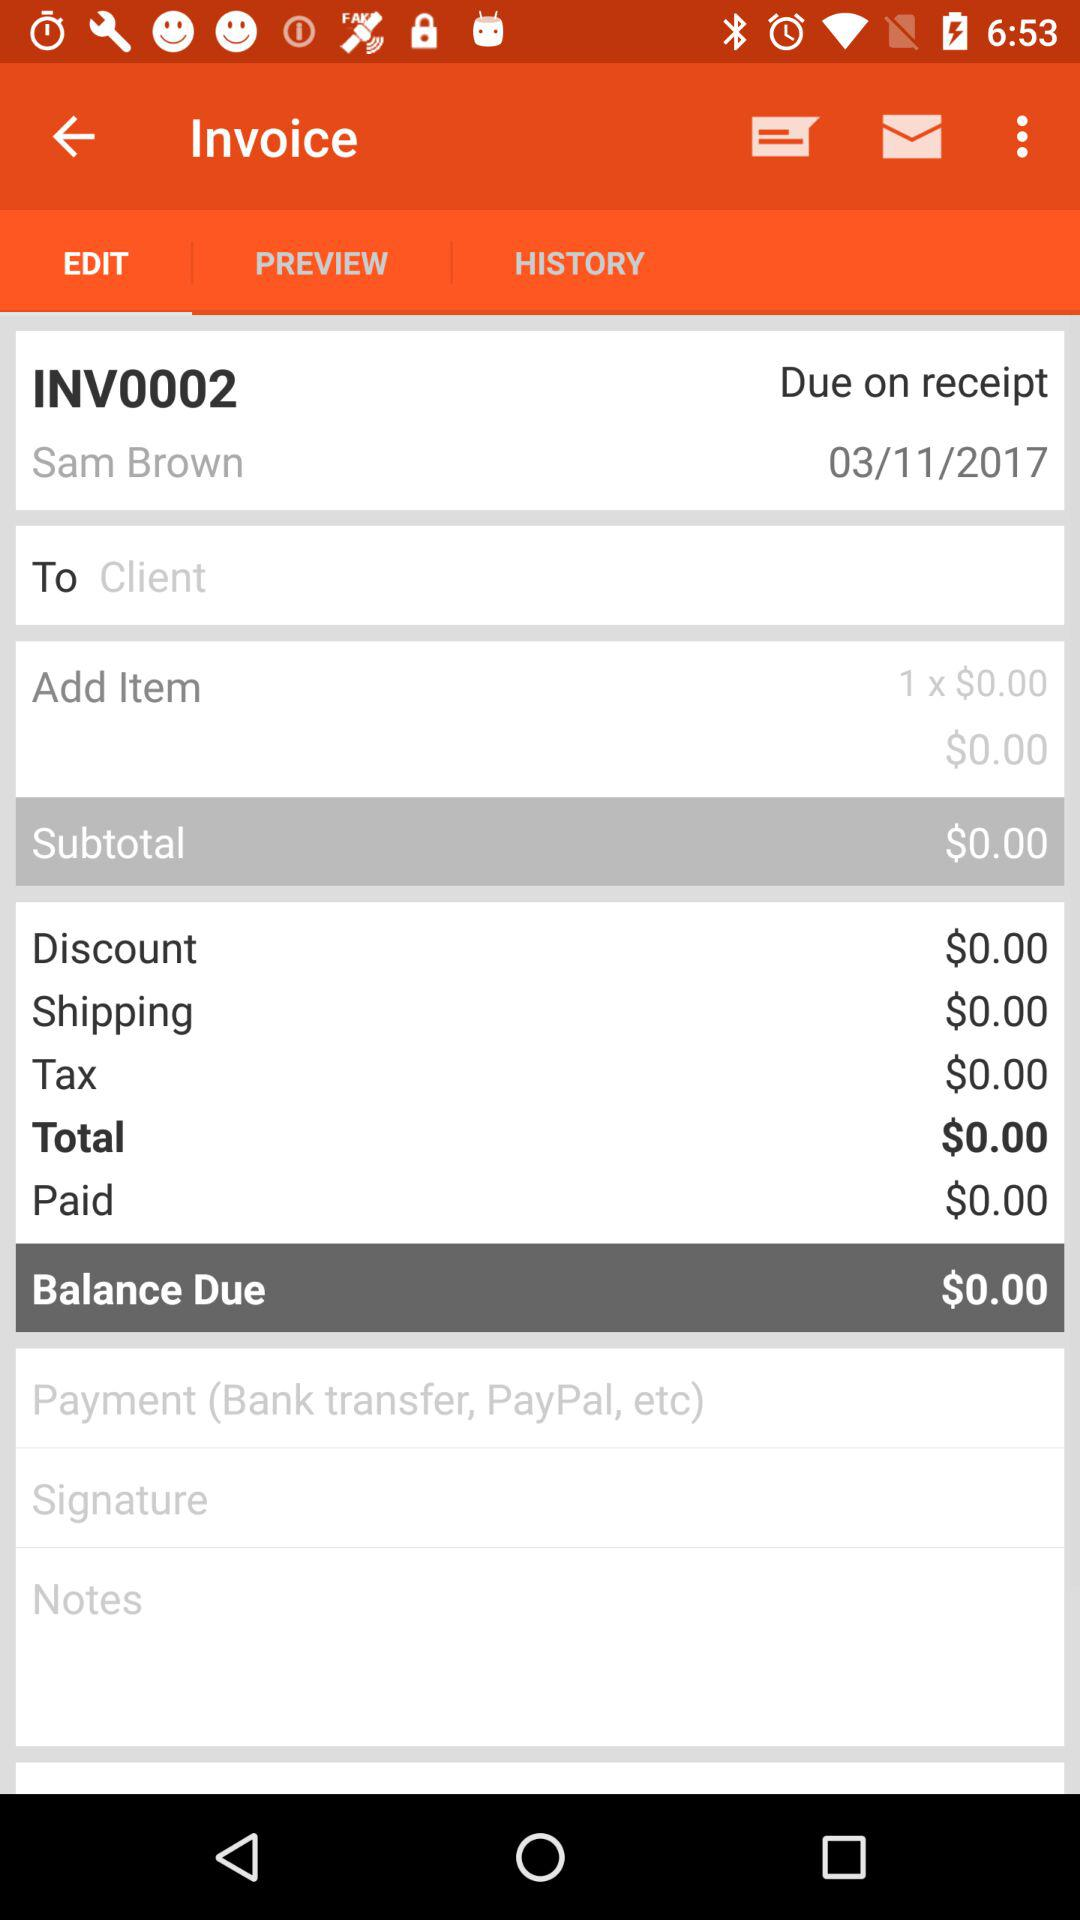What is the total amount of the invoice?
Answer the question using a single word or phrase. $0.00 